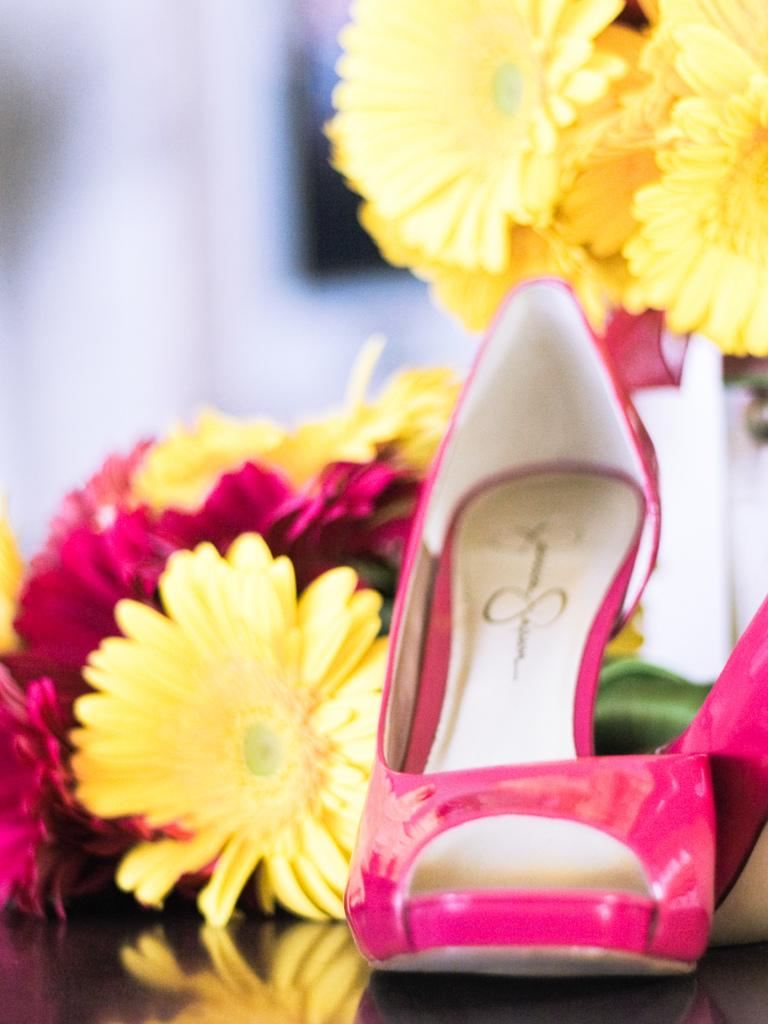What type of footwear is visible in the image? There are sandals in pink color in the image. What type of flowers can be seen in the image? There are flowers in yellow and red colors in the image. Can you describe the background of the image? The background of the image is blurred. What is the position of the leg wearing the pink sandals in the image? There is no leg visible in the image, only the pink sandals. 